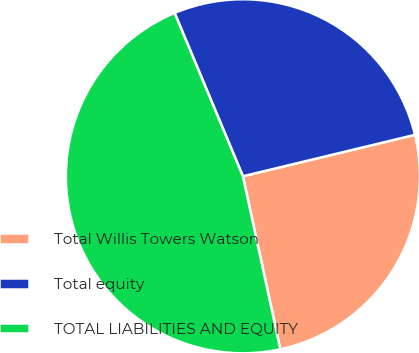Convert chart to OTSL. <chart><loc_0><loc_0><loc_500><loc_500><pie_chart><fcel>Total Willis Towers Watson<fcel>Total equity<fcel>TOTAL LIABILITIES AND EQUITY<nl><fcel>25.37%<fcel>27.54%<fcel>47.09%<nl></chart> 